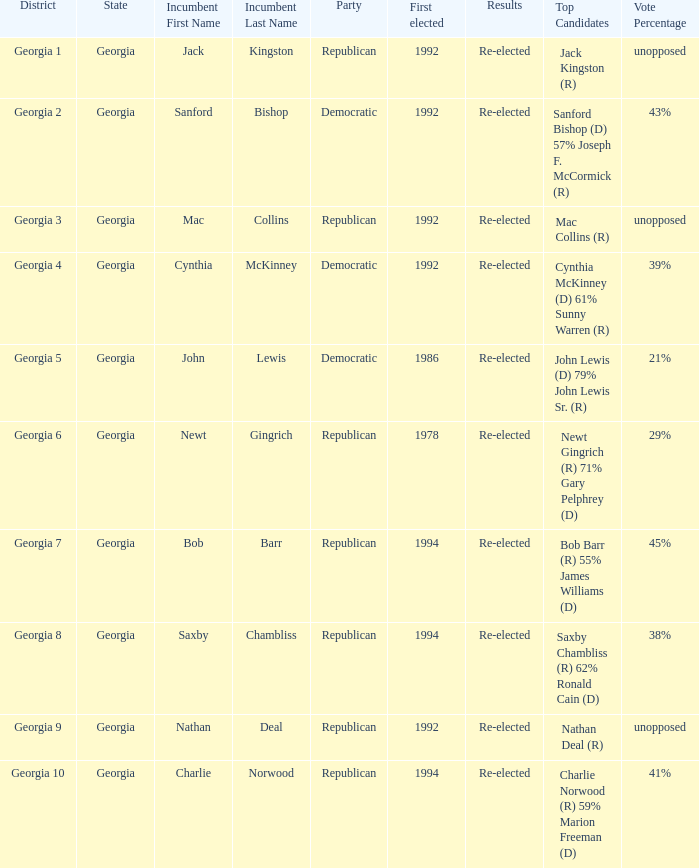Who were the contenders in the election where saxby chambliss was the incumbent? Saxby Chambliss (R) 62% Ronald Cain (D) 38%. 